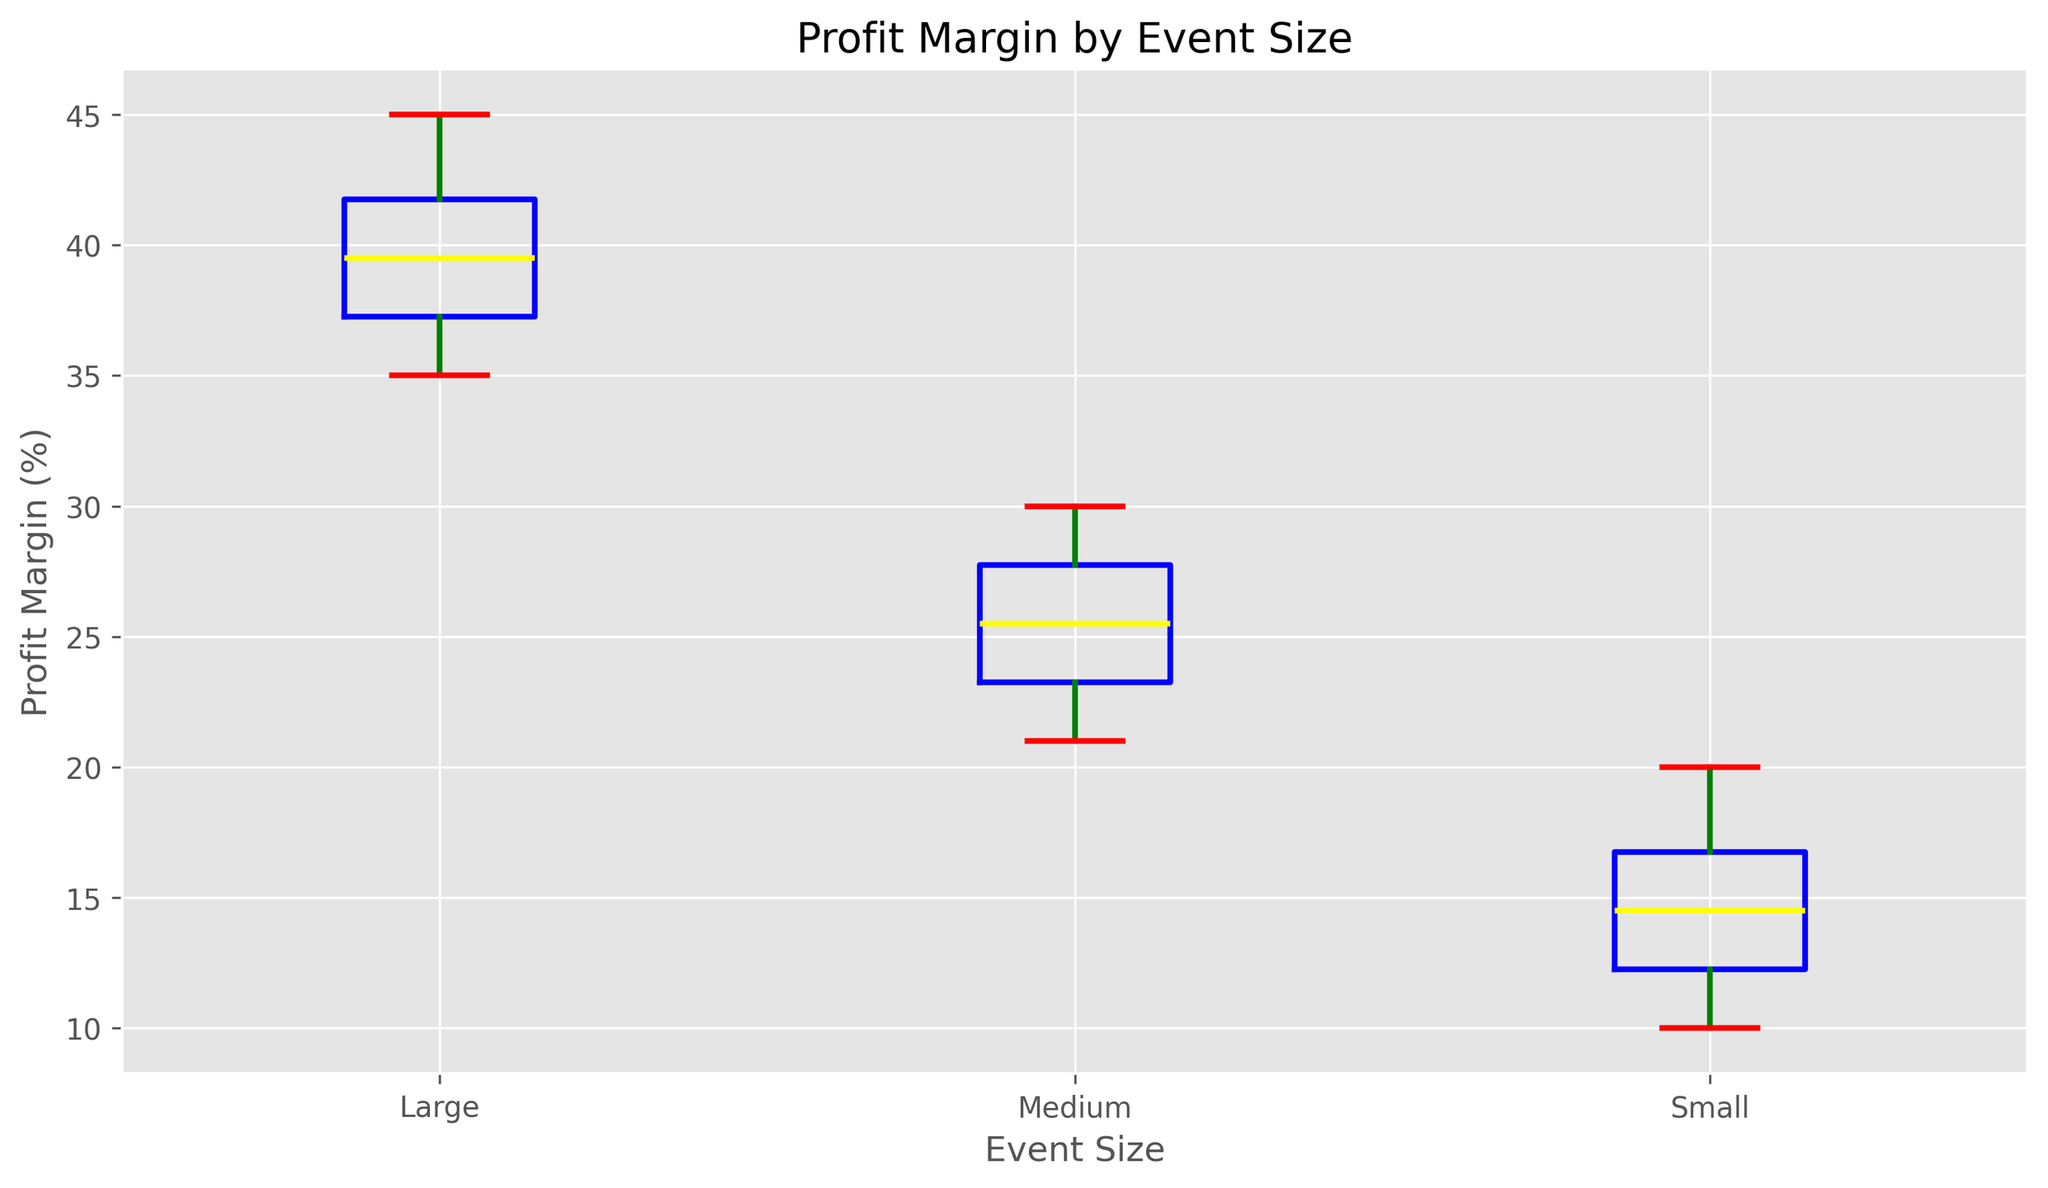What is the median profit margin for medium-sized events? The box plot shows that the median, represented by the line within the box, is at 26% for medium-sized events. Simply read the value from this line.
Answer: 26% Which event size has the highest maximum profit margin? To find the highest maximum profit margin, compare the topmost tips of the whiskers or the topmost data points. The whisker for large events reaches around 45%, which is higher than the maximum values for small and medium events.
Answer: Large What is the interquartile range (IQR) for small events? The interquartile range (IQR) is the difference between the third quartile (Q3) and the first quartile (Q1). For small events, Q3 is approximately 17, and Q1 is approximately 12. Calculate IQR as 17 - 12.
Answer: 5 How do median profit margins compare between small and large events? Compare the medians shown by the lines within the boxes for small and large events. The small events median is 14%, and the large events median is 40%.
Answer: The median for large events is higher Identify the event size with the widest range of profit margins. Range is determined by the distance between the minimum and maximum values. For small events, the range is 20-10 = 10; for medium, it’s 30-21 = 9; for large, it’s 45-35 = 10. Both small and large events have a range of 10, but large events have a more visually prominent wide range with extreme values.
Answer: Small and Large (both 10) Which event size has the lowest variability in profit margins? Variability can often be inferred from the spread within the box and whiskers. Medium-sized events show the smallest range between Q1 and Q3 and the entire span from minimum to maximum.
Answer: Medium What visual cues indicate the median profit margin in each box plot? The median is represented by the line within the box for each event size. Simply identify this line in each respective box plot.
Answer: A line within the box What color is used to represent the whiskers in the box plot? The whiskers are represented in green as visually indicated by the color of the lines extending from the top and bottom of each box.
Answer: Green What color are the box boundaries in the chart? The box boundaries are shown in blue, which encases the interquartile range for each event size.
Answer: Blue How does the spread of profit margins for large events compare to small events? Visually, the spread within the boxes and whiskers for small events spans from around 10 to 20, while for large events it spans from about 35 to 45. This indicates a similar range of spread for both but at different value levels.
Answer: Similar spread but at different value levels 